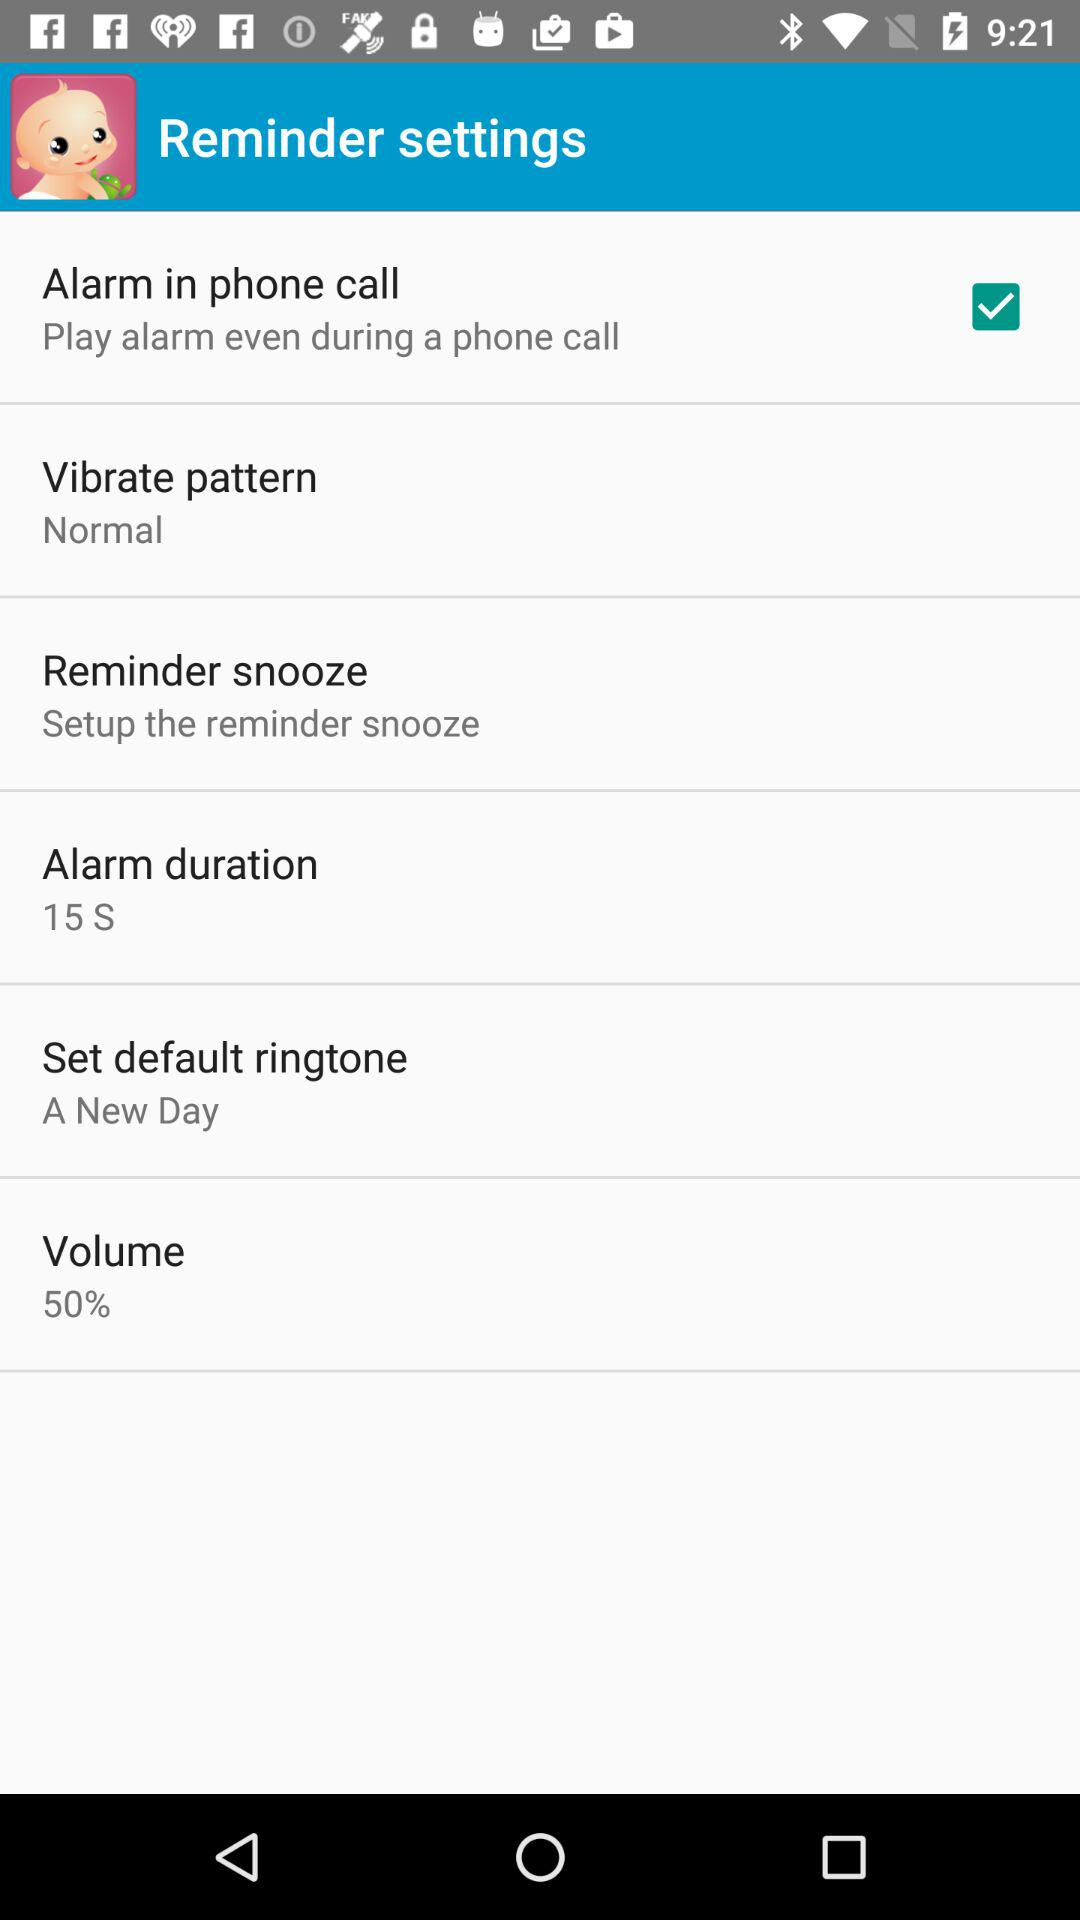What is the percentage for volume? The percentage for volume is 50. 